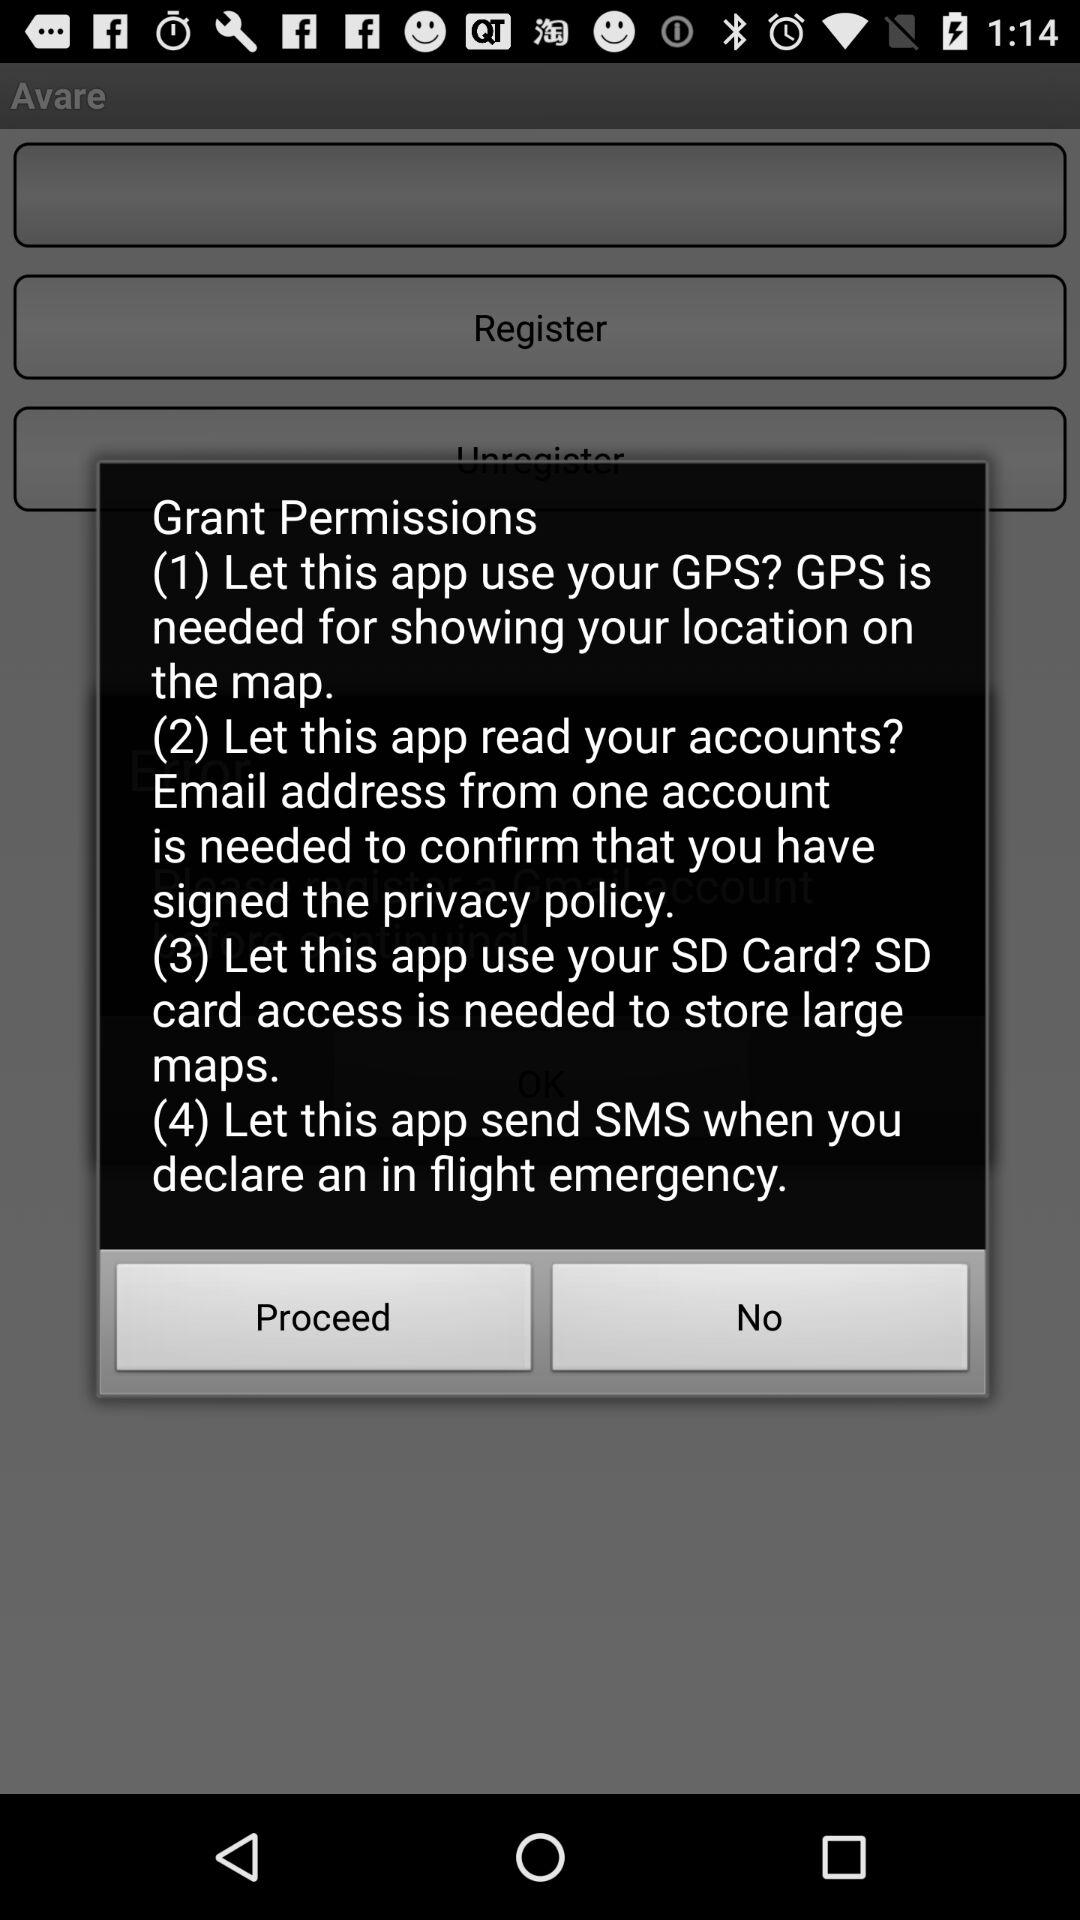What are the permissions that the application wants? The permissions that the application wants are "Let this app use your GPS", "Let this app read your accounts", "Let this app use your SD Card", and "Let this app send SMS when you declare an in flight emergency". 